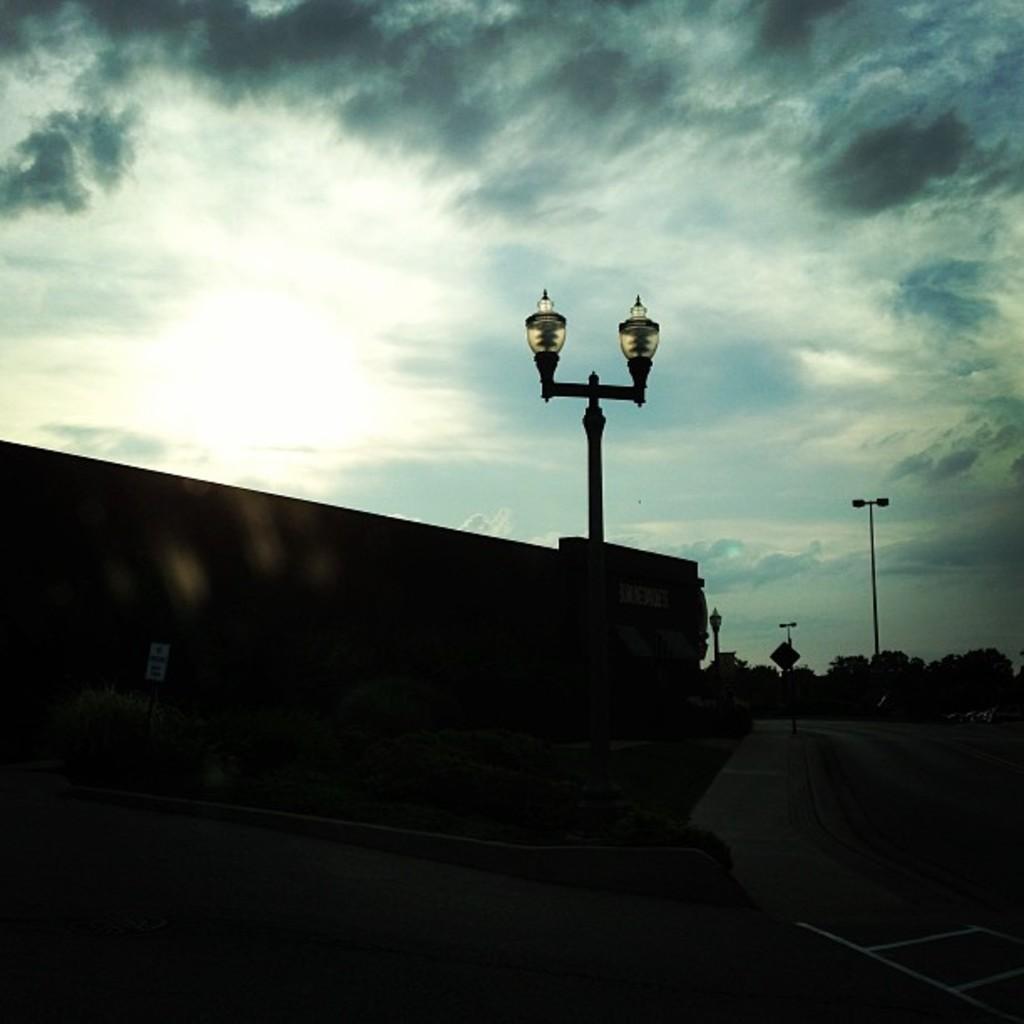How would you summarize this image in a sentence or two? In this picture there is a road in the right side. In the left there is a wall, before the wall there are some plants. In the center there is a street light. In the top there is a blue sky. 